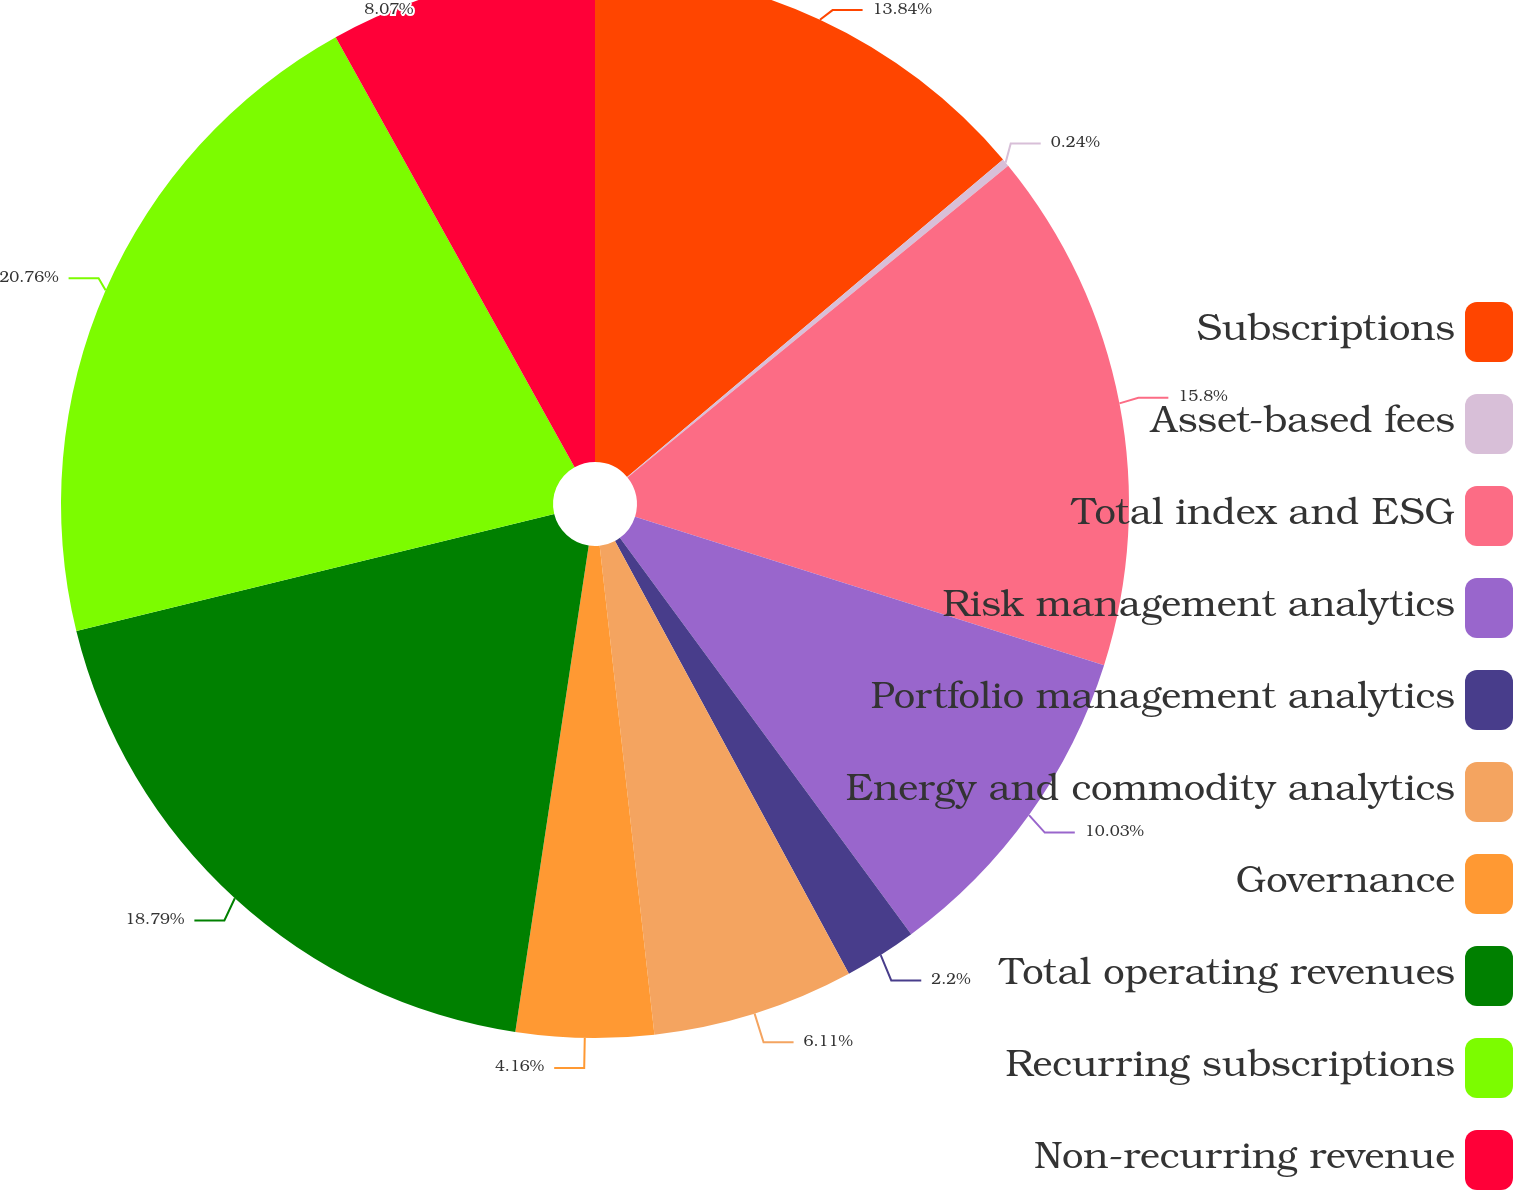Convert chart. <chart><loc_0><loc_0><loc_500><loc_500><pie_chart><fcel>Subscriptions<fcel>Asset-based fees<fcel>Total index and ESG<fcel>Risk management analytics<fcel>Portfolio management analytics<fcel>Energy and commodity analytics<fcel>Governance<fcel>Total operating revenues<fcel>Recurring subscriptions<fcel>Non-recurring revenue<nl><fcel>13.84%<fcel>0.24%<fcel>15.8%<fcel>10.03%<fcel>2.2%<fcel>6.11%<fcel>4.16%<fcel>18.79%<fcel>20.75%<fcel>8.07%<nl></chart> 